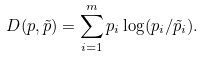Convert formula to latex. <formula><loc_0><loc_0><loc_500><loc_500>D ( p , \tilde { p } ) = \sum _ { i = 1 } ^ { m } p _ { i } \log ( p _ { i } / \tilde { p } _ { i } ) .</formula> 